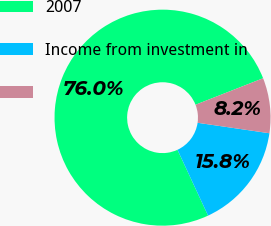Convert chart to OTSL. <chart><loc_0><loc_0><loc_500><loc_500><pie_chart><fcel>2007<fcel>Income from investment in<fcel>Unnamed: 2<nl><fcel>75.98%<fcel>15.77%<fcel>8.25%<nl></chart> 